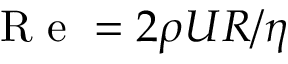Convert formula to latex. <formula><loc_0><loc_0><loc_500><loc_500>R e = 2 \rho U R / \eta</formula> 